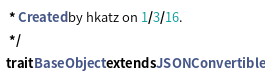<code> <loc_0><loc_0><loc_500><loc_500><_Scala_> * Created by hkatz on 1/3/16.
 */
trait BaseObject extends JSONConvertible
</code> 